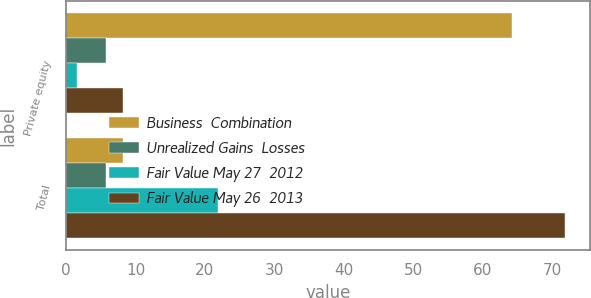Convert chart. <chart><loc_0><loc_0><loc_500><loc_500><stacked_bar_chart><ecel><fcel>Private equity<fcel>Total<nl><fcel>Business  Combination<fcel>64.2<fcel>8.2<nl><fcel>Unrealized Gains  Losses<fcel>5.8<fcel>5.8<nl><fcel>Fair Value May 27  2012<fcel>1.6<fcel>21.9<nl><fcel>Fair Value May 26  2013<fcel>8.2<fcel>71.9<nl></chart> 